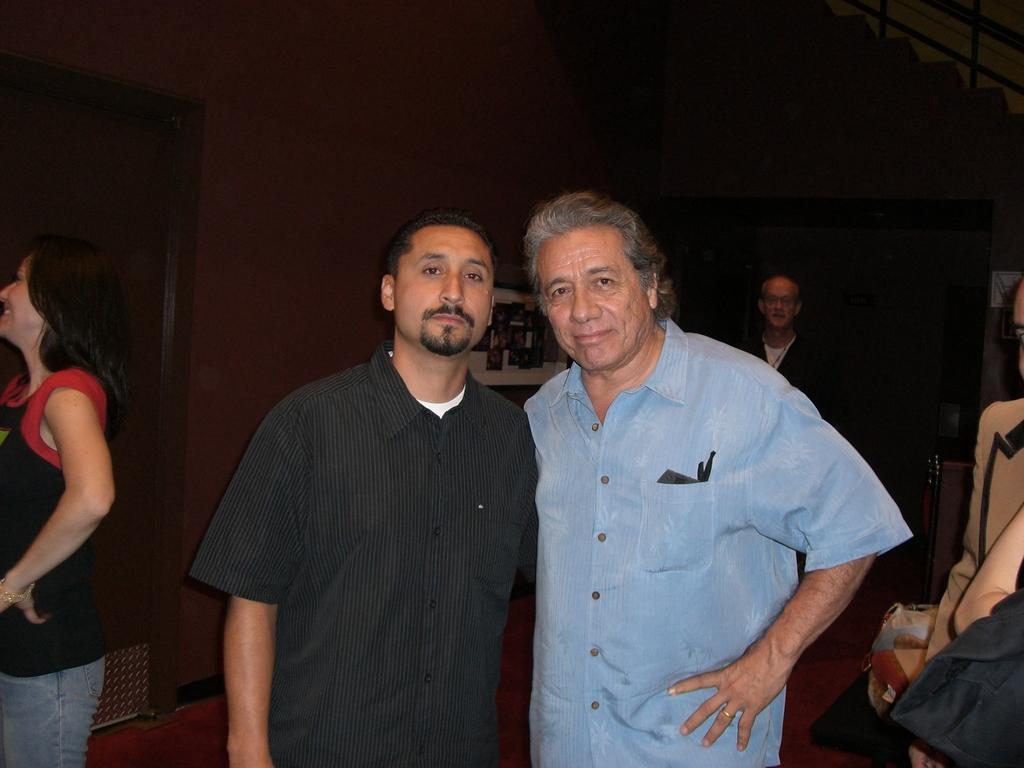Can you describe this image briefly? Here I can see two men standing and giving pose for the picture. In the background, I can see some more people. On the left side there is a woman standing facing towards the left side and smiling. In the background, I can see a wall in the dark. 